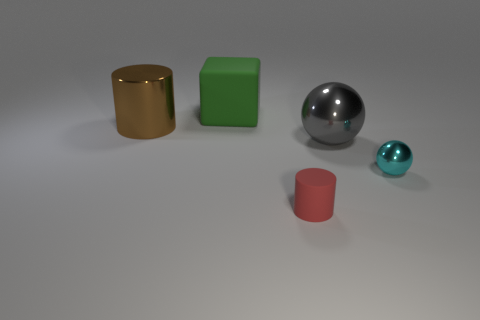Add 5 big red cubes. How many objects exist? 10 Subtract all cylinders. How many objects are left? 3 Add 4 big gray matte objects. How many big gray matte objects exist? 4 Subtract 1 gray balls. How many objects are left? 4 Subtract all tiny rubber things. Subtract all small rubber things. How many objects are left? 3 Add 5 brown metal cylinders. How many brown metal cylinders are left? 6 